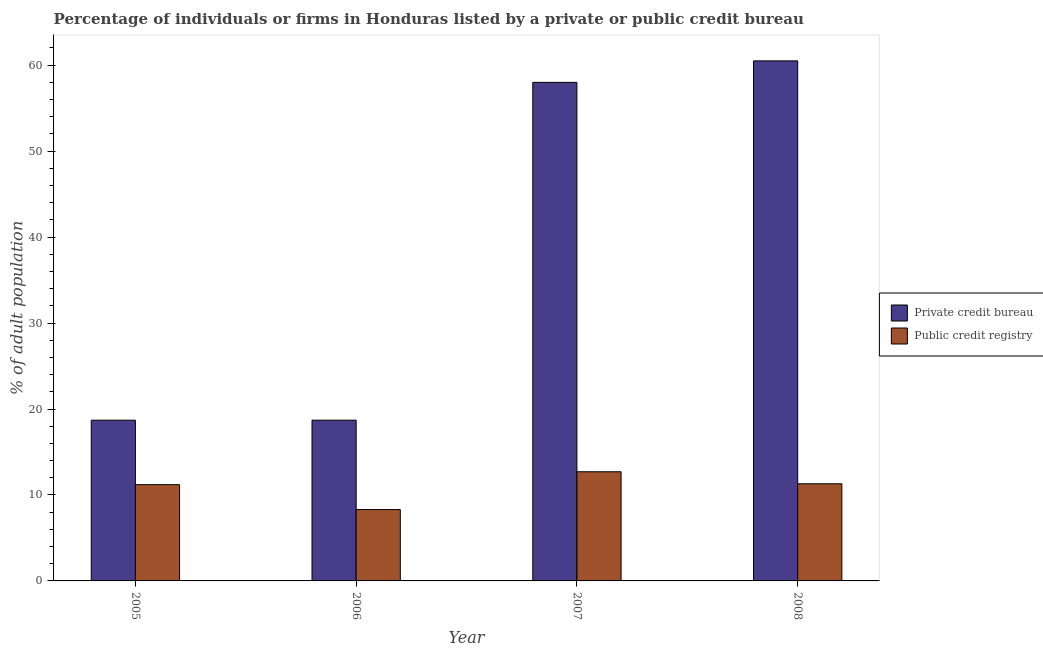How many bars are there on the 4th tick from the left?
Provide a short and direct response. 2. How many bars are there on the 2nd tick from the right?
Give a very brief answer. 2. What is the label of the 4th group of bars from the left?
Offer a terse response. 2008. In how many cases, is the number of bars for a given year not equal to the number of legend labels?
Offer a very short reply. 0. What is the percentage of firms listed by private credit bureau in 2006?
Keep it short and to the point. 18.7. Across all years, what is the minimum percentage of firms listed by private credit bureau?
Make the answer very short. 18.7. In which year was the percentage of firms listed by public credit bureau minimum?
Your answer should be very brief. 2006. What is the total percentage of firms listed by private credit bureau in the graph?
Offer a very short reply. 155.9. What is the average percentage of firms listed by private credit bureau per year?
Your answer should be very brief. 38.98. Is the percentage of firms listed by private credit bureau in 2005 less than that in 2007?
Provide a succinct answer. Yes. What is the difference between the highest and the lowest percentage of firms listed by private credit bureau?
Ensure brevity in your answer.  41.8. In how many years, is the percentage of firms listed by public credit bureau greater than the average percentage of firms listed by public credit bureau taken over all years?
Provide a succinct answer. 3. Is the sum of the percentage of firms listed by private credit bureau in 2007 and 2008 greater than the maximum percentage of firms listed by public credit bureau across all years?
Offer a terse response. Yes. What does the 2nd bar from the left in 2005 represents?
Give a very brief answer. Public credit registry. What does the 2nd bar from the right in 2007 represents?
Offer a very short reply. Private credit bureau. How many bars are there?
Offer a very short reply. 8. Are all the bars in the graph horizontal?
Offer a very short reply. No. What is the difference between two consecutive major ticks on the Y-axis?
Your answer should be very brief. 10. Does the graph contain grids?
Your response must be concise. No. Where does the legend appear in the graph?
Make the answer very short. Center right. How many legend labels are there?
Your response must be concise. 2. How are the legend labels stacked?
Provide a short and direct response. Vertical. What is the title of the graph?
Your answer should be very brief. Percentage of individuals or firms in Honduras listed by a private or public credit bureau. Does "Resident" appear as one of the legend labels in the graph?
Give a very brief answer. No. What is the label or title of the Y-axis?
Offer a terse response. % of adult population. What is the % of adult population of Public credit registry in 2005?
Your answer should be very brief. 11.2. What is the % of adult population of Private credit bureau in 2006?
Give a very brief answer. 18.7. What is the % of adult population of Private credit bureau in 2008?
Keep it short and to the point. 60.5. What is the % of adult population in Public credit registry in 2008?
Offer a terse response. 11.3. Across all years, what is the maximum % of adult population of Private credit bureau?
Your answer should be very brief. 60.5. Across all years, what is the maximum % of adult population in Public credit registry?
Your answer should be compact. 12.7. Across all years, what is the minimum % of adult population in Private credit bureau?
Make the answer very short. 18.7. What is the total % of adult population in Private credit bureau in the graph?
Offer a very short reply. 155.9. What is the total % of adult population in Public credit registry in the graph?
Make the answer very short. 43.5. What is the difference between the % of adult population in Private credit bureau in 2005 and that in 2006?
Offer a terse response. 0. What is the difference between the % of adult population of Public credit registry in 2005 and that in 2006?
Offer a terse response. 2.9. What is the difference between the % of adult population in Private credit bureau in 2005 and that in 2007?
Give a very brief answer. -39.3. What is the difference between the % of adult population in Public credit registry in 2005 and that in 2007?
Provide a succinct answer. -1.5. What is the difference between the % of adult population in Private credit bureau in 2005 and that in 2008?
Your response must be concise. -41.8. What is the difference between the % of adult population of Public credit registry in 2005 and that in 2008?
Your response must be concise. -0.1. What is the difference between the % of adult population in Private credit bureau in 2006 and that in 2007?
Ensure brevity in your answer.  -39.3. What is the difference between the % of adult population in Private credit bureau in 2006 and that in 2008?
Offer a very short reply. -41.8. What is the difference between the % of adult population in Public credit registry in 2006 and that in 2008?
Offer a very short reply. -3. What is the difference between the % of adult population of Public credit registry in 2007 and that in 2008?
Your answer should be very brief. 1.4. What is the difference between the % of adult population in Private credit bureau in 2005 and the % of adult population in Public credit registry in 2007?
Offer a terse response. 6. What is the difference between the % of adult population of Private credit bureau in 2006 and the % of adult population of Public credit registry in 2007?
Offer a terse response. 6. What is the difference between the % of adult population in Private credit bureau in 2007 and the % of adult population in Public credit registry in 2008?
Provide a short and direct response. 46.7. What is the average % of adult population of Private credit bureau per year?
Give a very brief answer. 38.98. What is the average % of adult population of Public credit registry per year?
Offer a terse response. 10.88. In the year 2006, what is the difference between the % of adult population of Private credit bureau and % of adult population of Public credit registry?
Ensure brevity in your answer.  10.4. In the year 2007, what is the difference between the % of adult population of Private credit bureau and % of adult population of Public credit registry?
Provide a succinct answer. 45.3. In the year 2008, what is the difference between the % of adult population of Private credit bureau and % of adult population of Public credit registry?
Give a very brief answer. 49.2. What is the ratio of the % of adult population in Private credit bureau in 2005 to that in 2006?
Give a very brief answer. 1. What is the ratio of the % of adult population in Public credit registry in 2005 to that in 2006?
Keep it short and to the point. 1.35. What is the ratio of the % of adult population in Private credit bureau in 2005 to that in 2007?
Offer a very short reply. 0.32. What is the ratio of the % of adult population in Public credit registry in 2005 to that in 2007?
Provide a succinct answer. 0.88. What is the ratio of the % of adult population of Private credit bureau in 2005 to that in 2008?
Offer a very short reply. 0.31. What is the ratio of the % of adult population in Private credit bureau in 2006 to that in 2007?
Provide a short and direct response. 0.32. What is the ratio of the % of adult population in Public credit registry in 2006 to that in 2007?
Your answer should be very brief. 0.65. What is the ratio of the % of adult population in Private credit bureau in 2006 to that in 2008?
Your response must be concise. 0.31. What is the ratio of the % of adult population in Public credit registry in 2006 to that in 2008?
Keep it short and to the point. 0.73. What is the ratio of the % of adult population of Private credit bureau in 2007 to that in 2008?
Your answer should be compact. 0.96. What is the ratio of the % of adult population of Public credit registry in 2007 to that in 2008?
Your answer should be very brief. 1.12. What is the difference between the highest and the second highest % of adult population of Public credit registry?
Ensure brevity in your answer.  1.4. What is the difference between the highest and the lowest % of adult population of Private credit bureau?
Your answer should be very brief. 41.8. 